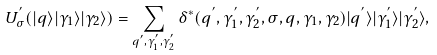Convert formula to latex. <formula><loc_0><loc_0><loc_500><loc_500>U _ { \sigma } ^ { ^ { \prime } } ( | q \rangle | \gamma _ { 1 } \rangle | \gamma _ { 2 } \rangle ) = \sum _ { q ^ { ^ { \prime } } , \gamma _ { 1 } ^ { ^ { \prime } } , \gamma _ { 2 } ^ { ^ { \prime } } } \delta ^ { * } ( q ^ { ^ { \prime } } , \gamma _ { 1 } ^ { ^ { \prime } } , \gamma _ { 2 } ^ { ^ { \prime } } , \sigma , q , \gamma _ { 1 } , \gamma _ { 2 } ) | q ^ { ^ { \prime } } \rangle | \gamma _ { 1 } ^ { ^ { \prime } } \rangle | \gamma _ { 2 } ^ { ^ { \prime } } \rangle ,</formula> 